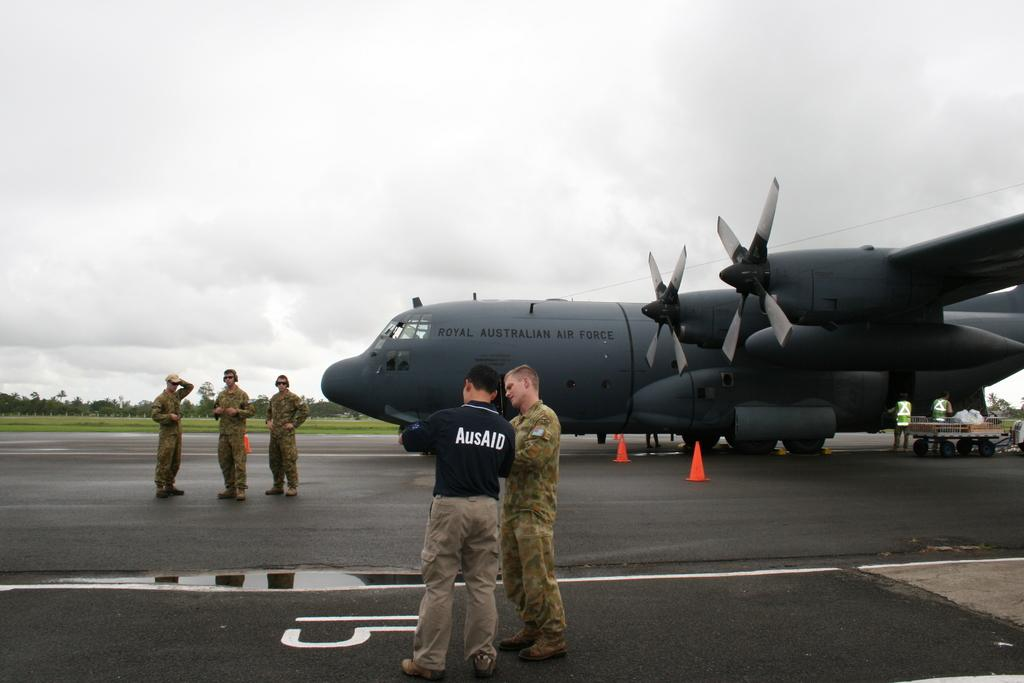<image>
Present a compact description of the photo's key features. A few people standing next to a royal australian airplane 